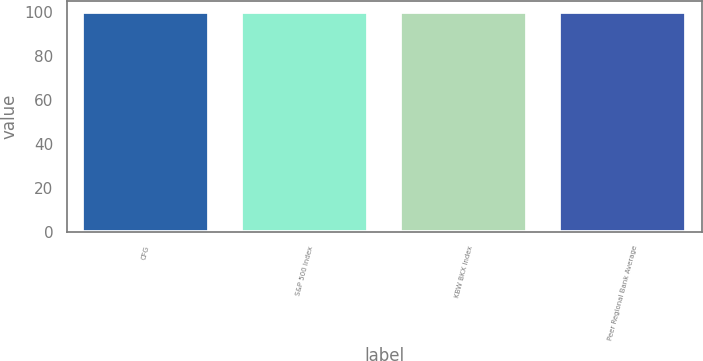Convert chart. <chart><loc_0><loc_0><loc_500><loc_500><bar_chart><fcel>CFG<fcel>S&P 500 Index<fcel>KBW BKX Index<fcel>Peer Regional Bank Average<nl><fcel>100<fcel>100.1<fcel>100.2<fcel>100.3<nl></chart> 